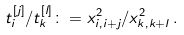Convert formula to latex. <formula><loc_0><loc_0><loc_500><loc_500>t ^ { [ j ] } _ { i } / t ^ { [ l ] } _ { k } \colon = { x _ { i , i + j } ^ { 2 } } / { x _ { k , k + l } ^ { 2 } } \, .</formula> 